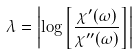Convert formula to latex. <formula><loc_0><loc_0><loc_500><loc_500>\lambda = \left | \log \left [ \frac { \chi ^ { \prime } ( \omega ) } { \chi ^ { \prime \prime } ( \omega ) } \right ] \right |</formula> 